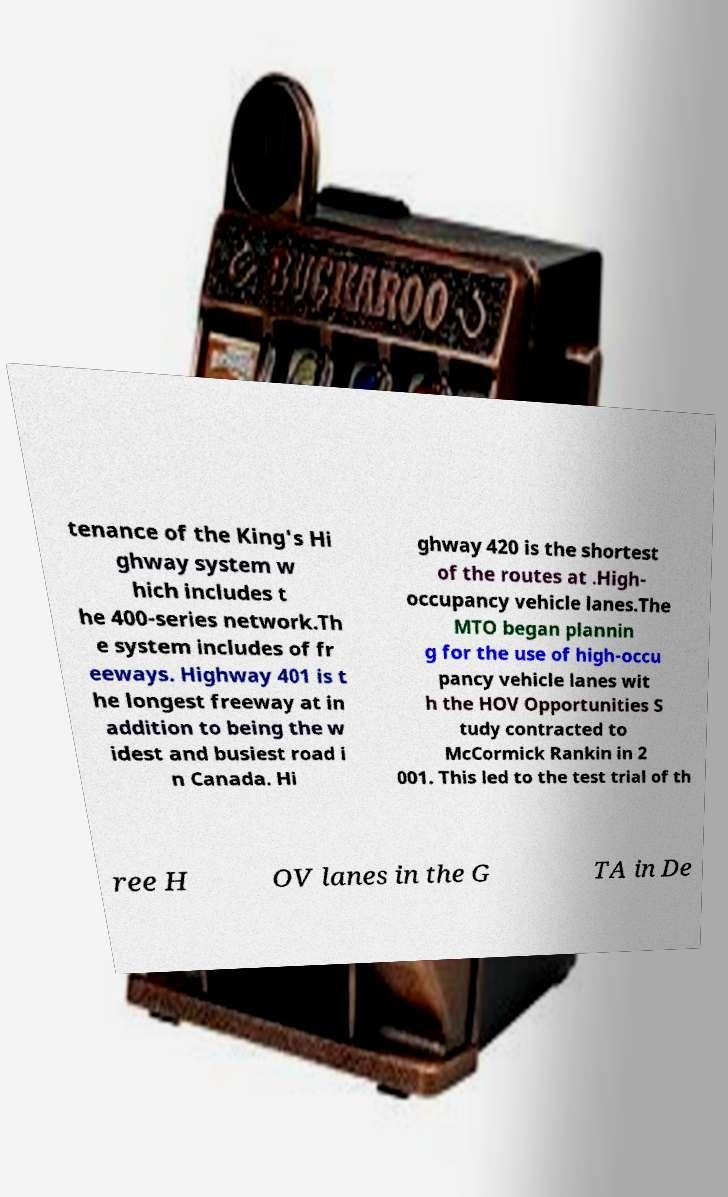Can you accurately transcribe the text from the provided image for me? tenance of the King's Hi ghway system w hich includes t he 400-series network.Th e system includes of fr eeways. Highway 401 is t he longest freeway at in addition to being the w idest and busiest road i n Canada. Hi ghway 420 is the shortest of the routes at .High- occupancy vehicle lanes.The MTO began plannin g for the use of high-occu pancy vehicle lanes wit h the HOV Opportunities S tudy contracted to McCormick Rankin in 2 001. This led to the test trial of th ree H OV lanes in the G TA in De 